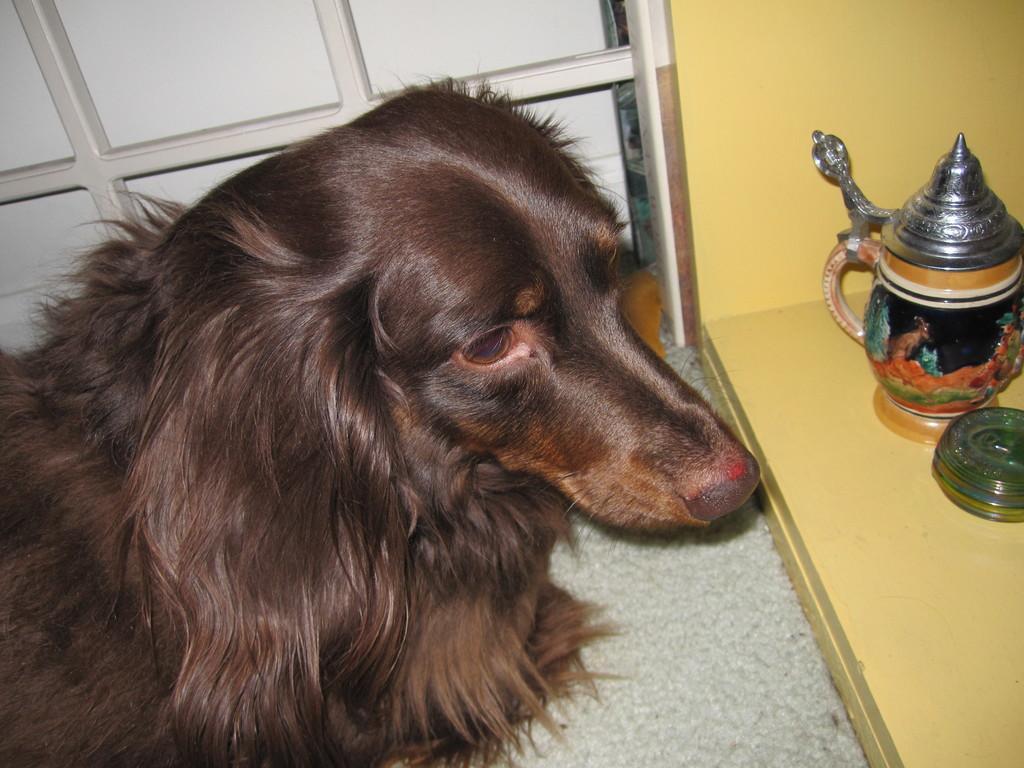How would you summarize this image in a sentence or two? On the left side of this image there is a dog facing towards the right side. On the right side there is a jar on a wooden plank. At the top of the image there is a metal frame. 